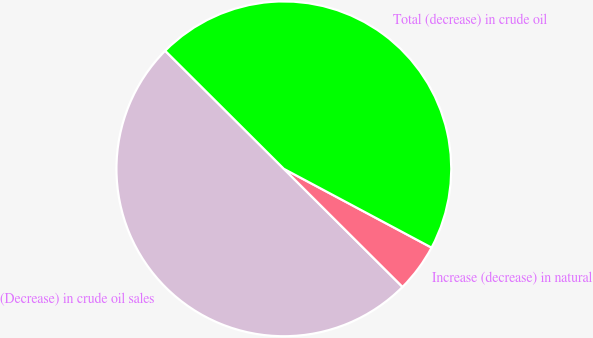Convert chart to OTSL. <chart><loc_0><loc_0><loc_500><loc_500><pie_chart><fcel>(Decrease) in crude oil sales<fcel>Increase (decrease) in natural<fcel>Total (decrease) in crude oil<nl><fcel>50.0%<fcel>4.66%<fcel>45.34%<nl></chart> 